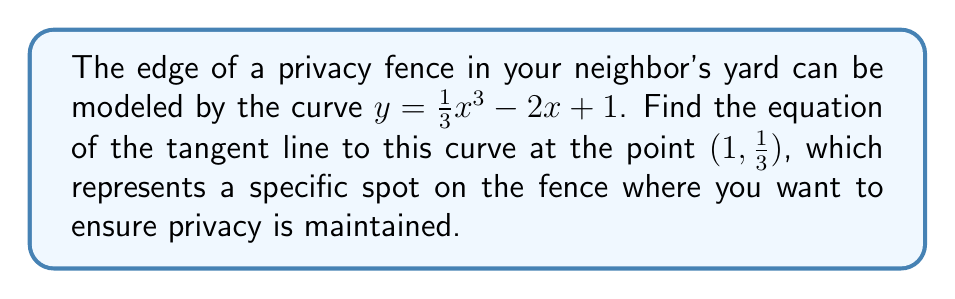Give your solution to this math problem. To find the equation of the tangent line, we need to follow these steps:

1) The general equation of a tangent line is $y - y_1 = m(x - x_1)$, where $(x_1, y_1)$ is the point of tangency and $m$ is the slope of the tangent line.

2) We're given the point $(1, \frac{1}{3})$, so $x_1 = 1$ and $y_1 = \frac{1}{3}$.

3) To find the slope $m$, we need to calculate the derivative of the curve function and evaluate it at $x = 1$:

   $f(x) = \frac{1}{3}x^3 - 2x + 1$
   $f'(x) = x^2 - 2$

4) Evaluate $f'(x)$ at $x = 1$:
   
   $f'(1) = 1^2 - 2 = -1$

5) Now we have all the components to form the equation of the tangent line:

   $y - \frac{1}{3} = -1(x - 1)$

6) Simplify:

   $y - \frac{1}{3} = -x + 1$
   $y = -x + \frac{4}{3}$

Therefore, the equation of the tangent line is $y = -x + \frac{4}{3}$.
Answer: $y = -x + \frac{4}{3}$ 